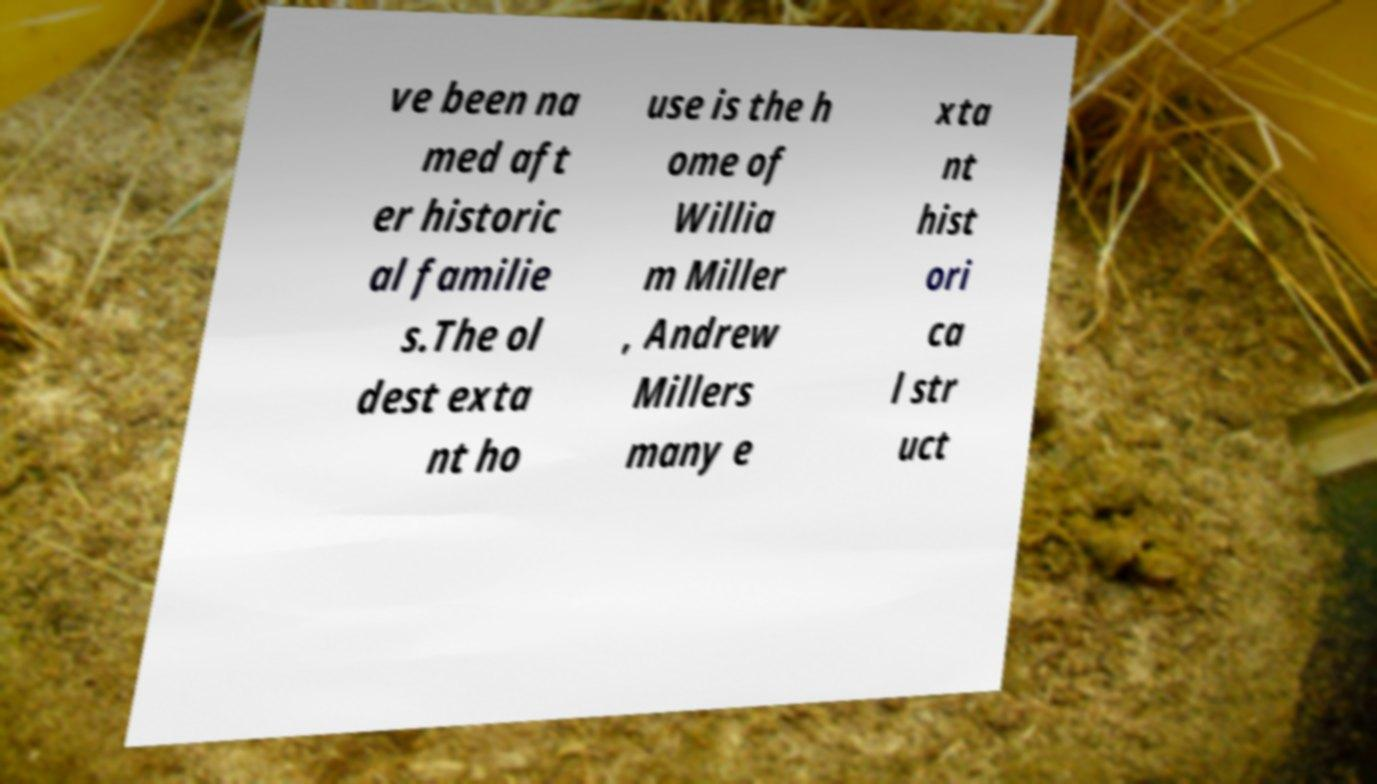Please identify and transcribe the text found in this image. ve been na med aft er historic al familie s.The ol dest exta nt ho use is the h ome of Willia m Miller , Andrew Millers many e xta nt hist ori ca l str uct 